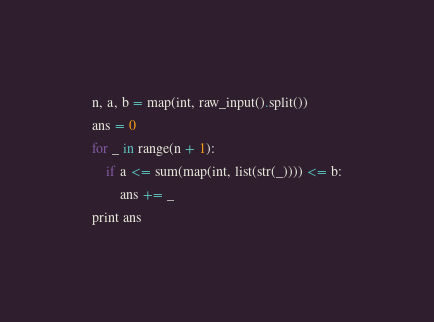Convert code to text. <code><loc_0><loc_0><loc_500><loc_500><_Python_>n, a, b = map(int, raw_input().split())
ans = 0
for _ in range(n + 1):
    if a <= sum(map(int, list(str(_)))) <= b:
        ans += _
print ans
</code> 